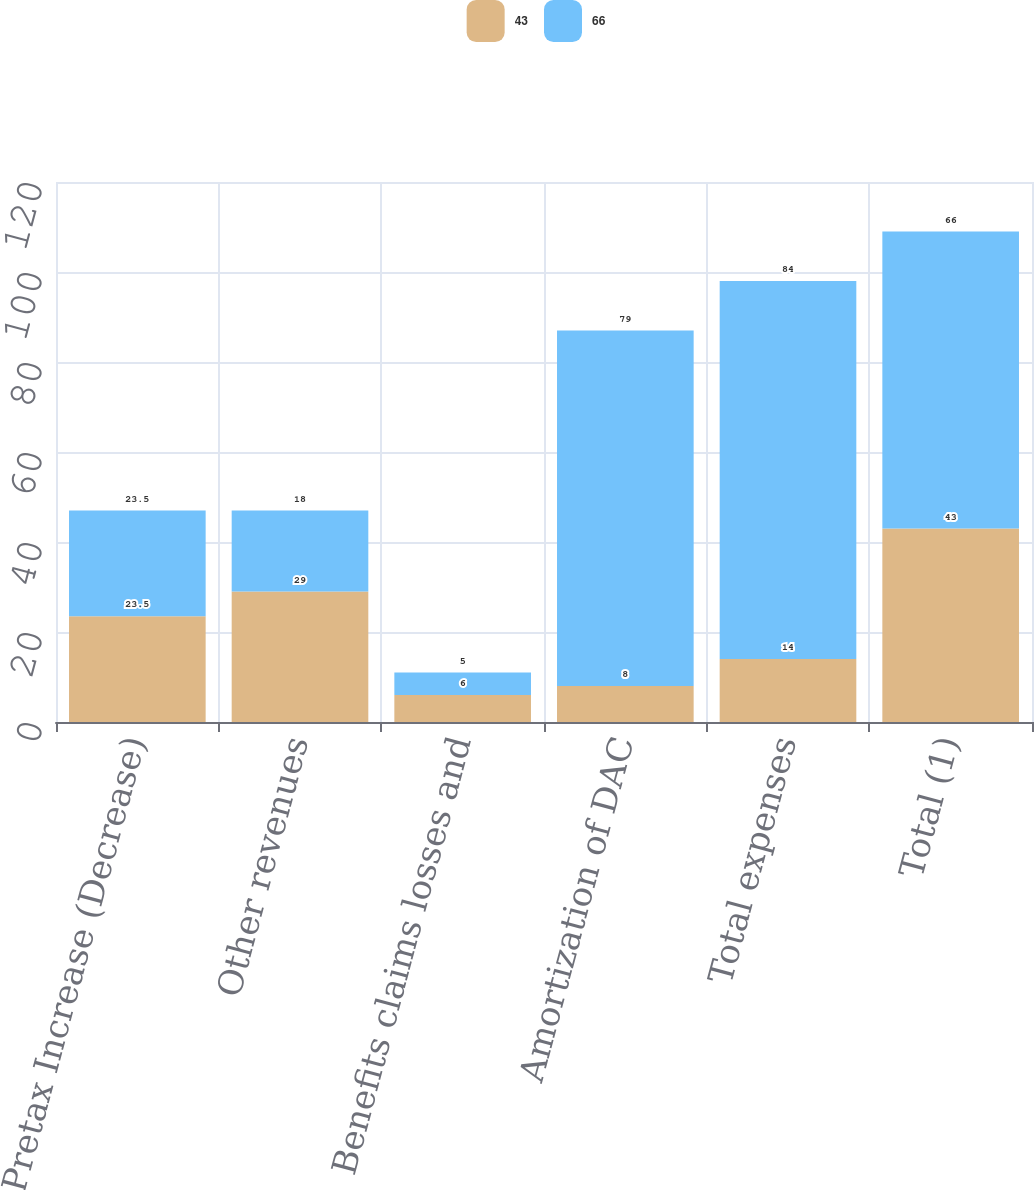Convert chart to OTSL. <chart><loc_0><loc_0><loc_500><loc_500><stacked_bar_chart><ecel><fcel>Pretax Increase (Decrease)<fcel>Other revenues<fcel>Benefits claims losses and<fcel>Amortization of DAC<fcel>Total expenses<fcel>Total (1)<nl><fcel>43<fcel>23.5<fcel>29<fcel>6<fcel>8<fcel>14<fcel>43<nl><fcel>66<fcel>23.5<fcel>18<fcel>5<fcel>79<fcel>84<fcel>66<nl></chart> 